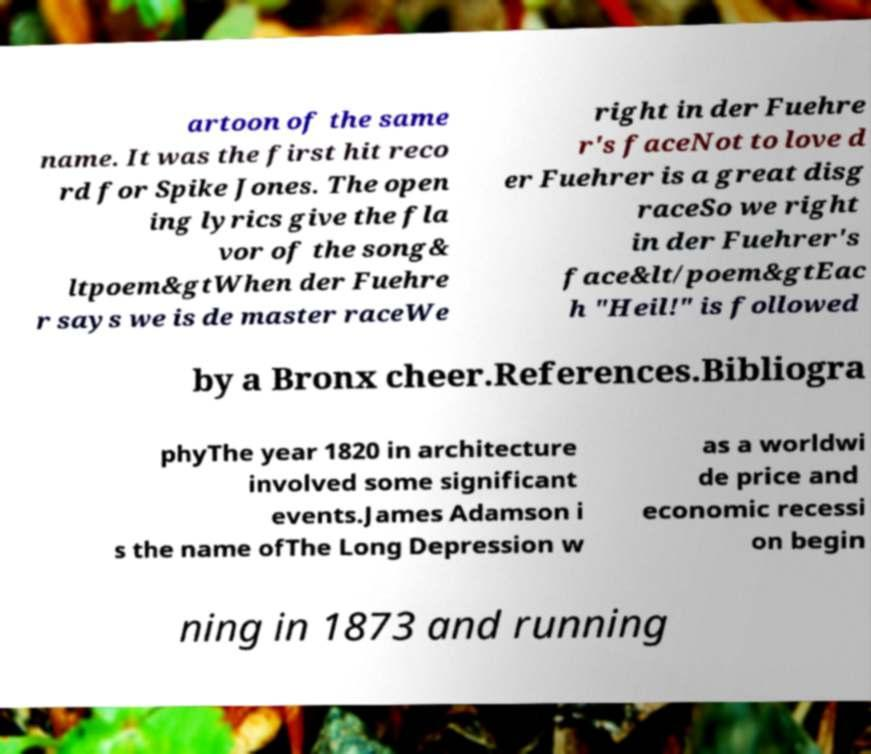Please read and relay the text visible in this image. What does it say? artoon of the same name. It was the first hit reco rd for Spike Jones. The open ing lyrics give the fla vor of the song& ltpoem&gtWhen der Fuehre r says we is de master raceWe right in der Fuehre r's faceNot to love d er Fuehrer is a great disg raceSo we right in der Fuehrer's face&lt/poem&gtEac h "Heil!" is followed by a Bronx cheer.References.Bibliogra phyThe year 1820 in architecture involved some significant events.James Adamson i s the name ofThe Long Depression w as a worldwi de price and economic recessi on begin ning in 1873 and running 